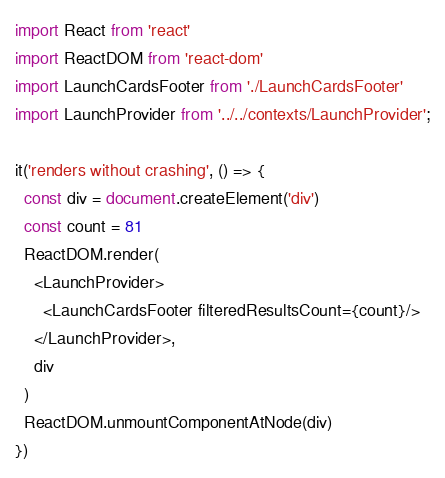<code> <loc_0><loc_0><loc_500><loc_500><_JavaScript_>import React from 'react'
import ReactDOM from 'react-dom'
import LaunchCardsFooter from './LaunchCardsFooter'
import LaunchProvider from '../../contexts/LaunchProvider';

it('renders without crashing', () => {
  const div = document.createElement('div')
  const count = 81
  ReactDOM.render(
    <LaunchProvider>
      <LaunchCardsFooter filteredResultsCount={count}/>
    </LaunchProvider>,
    div
  )
  ReactDOM.unmountComponentAtNode(div)
})</code> 